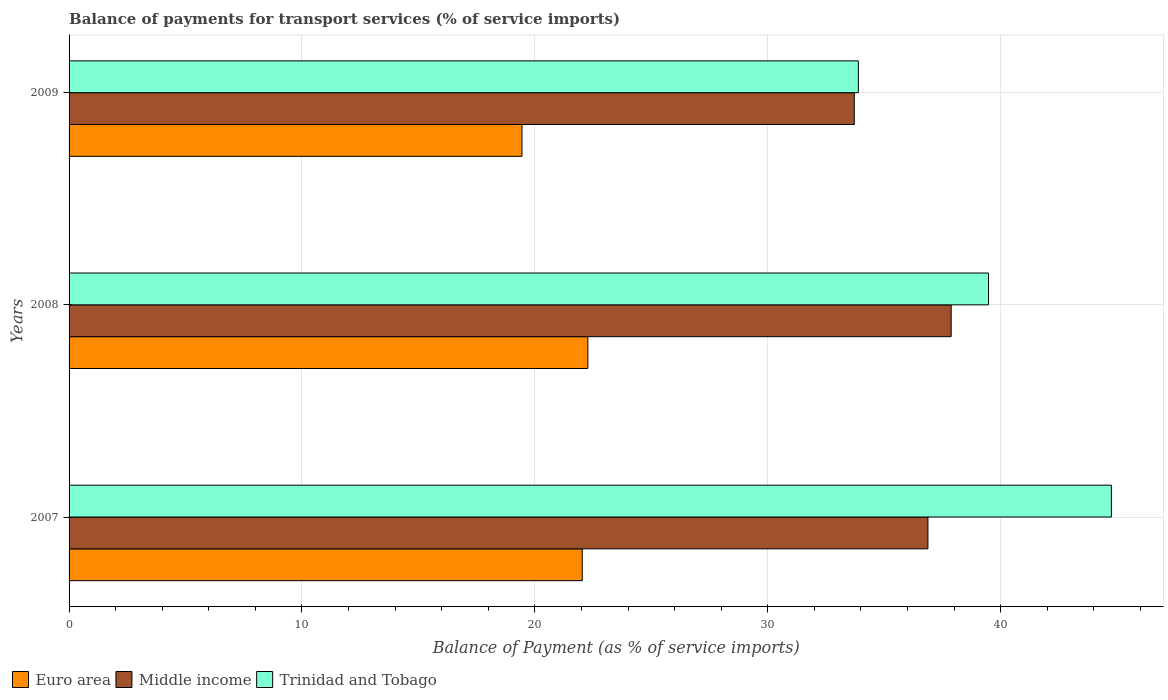How many groups of bars are there?
Offer a very short reply. 3. What is the balance of payments for transport services in Euro area in 2009?
Provide a succinct answer. 19.45. Across all years, what is the maximum balance of payments for transport services in Euro area?
Your response must be concise. 22.28. Across all years, what is the minimum balance of payments for transport services in Trinidad and Tobago?
Offer a terse response. 33.89. In which year was the balance of payments for transport services in Euro area maximum?
Your answer should be very brief. 2008. What is the total balance of payments for transport services in Trinidad and Tobago in the graph?
Your answer should be very brief. 118.12. What is the difference between the balance of payments for transport services in Trinidad and Tobago in 2007 and that in 2008?
Your answer should be very brief. 5.28. What is the difference between the balance of payments for transport services in Trinidad and Tobago in 2009 and the balance of payments for transport services in Middle income in 2008?
Provide a short and direct response. -3.99. What is the average balance of payments for transport services in Middle income per year?
Keep it short and to the point. 36.16. In the year 2007, what is the difference between the balance of payments for transport services in Middle income and balance of payments for transport services in Trinidad and Tobago?
Make the answer very short. -7.88. What is the ratio of the balance of payments for transport services in Euro area in 2007 to that in 2009?
Provide a succinct answer. 1.13. Is the difference between the balance of payments for transport services in Middle income in 2007 and 2009 greater than the difference between the balance of payments for transport services in Trinidad and Tobago in 2007 and 2009?
Your answer should be very brief. No. What is the difference between the highest and the second highest balance of payments for transport services in Trinidad and Tobago?
Give a very brief answer. 5.28. What is the difference between the highest and the lowest balance of payments for transport services in Trinidad and Tobago?
Offer a terse response. 10.86. What does the 1st bar from the bottom in 2009 represents?
Provide a short and direct response. Euro area. Are all the bars in the graph horizontal?
Offer a very short reply. Yes. Are the values on the major ticks of X-axis written in scientific E-notation?
Offer a terse response. No. Does the graph contain grids?
Your answer should be very brief. Yes. How are the legend labels stacked?
Your response must be concise. Horizontal. What is the title of the graph?
Offer a terse response. Balance of payments for transport services (% of service imports). What is the label or title of the X-axis?
Offer a very short reply. Balance of Payment (as % of service imports). What is the Balance of Payment (as % of service imports) in Euro area in 2007?
Your answer should be compact. 22.04. What is the Balance of Payment (as % of service imports) of Middle income in 2007?
Your answer should be compact. 36.88. What is the Balance of Payment (as % of service imports) in Trinidad and Tobago in 2007?
Ensure brevity in your answer.  44.75. What is the Balance of Payment (as % of service imports) in Euro area in 2008?
Offer a terse response. 22.28. What is the Balance of Payment (as % of service imports) in Middle income in 2008?
Your response must be concise. 37.88. What is the Balance of Payment (as % of service imports) of Trinidad and Tobago in 2008?
Your response must be concise. 39.48. What is the Balance of Payment (as % of service imports) in Euro area in 2009?
Your response must be concise. 19.45. What is the Balance of Payment (as % of service imports) of Middle income in 2009?
Offer a terse response. 33.72. What is the Balance of Payment (as % of service imports) in Trinidad and Tobago in 2009?
Give a very brief answer. 33.89. Across all years, what is the maximum Balance of Payment (as % of service imports) in Euro area?
Your response must be concise. 22.28. Across all years, what is the maximum Balance of Payment (as % of service imports) of Middle income?
Your response must be concise. 37.88. Across all years, what is the maximum Balance of Payment (as % of service imports) in Trinidad and Tobago?
Give a very brief answer. 44.75. Across all years, what is the minimum Balance of Payment (as % of service imports) in Euro area?
Make the answer very short. 19.45. Across all years, what is the minimum Balance of Payment (as % of service imports) in Middle income?
Give a very brief answer. 33.72. Across all years, what is the minimum Balance of Payment (as % of service imports) of Trinidad and Tobago?
Your answer should be compact. 33.89. What is the total Balance of Payment (as % of service imports) of Euro area in the graph?
Keep it short and to the point. 63.76. What is the total Balance of Payment (as % of service imports) in Middle income in the graph?
Your answer should be very brief. 108.47. What is the total Balance of Payment (as % of service imports) of Trinidad and Tobago in the graph?
Keep it short and to the point. 118.12. What is the difference between the Balance of Payment (as % of service imports) in Euro area in 2007 and that in 2008?
Give a very brief answer. -0.24. What is the difference between the Balance of Payment (as % of service imports) of Middle income in 2007 and that in 2008?
Make the answer very short. -1. What is the difference between the Balance of Payment (as % of service imports) in Trinidad and Tobago in 2007 and that in 2008?
Your answer should be compact. 5.28. What is the difference between the Balance of Payment (as % of service imports) of Euro area in 2007 and that in 2009?
Provide a short and direct response. 2.59. What is the difference between the Balance of Payment (as % of service imports) of Middle income in 2007 and that in 2009?
Keep it short and to the point. 3.16. What is the difference between the Balance of Payment (as % of service imports) in Trinidad and Tobago in 2007 and that in 2009?
Offer a terse response. 10.86. What is the difference between the Balance of Payment (as % of service imports) of Euro area in 2008 and that in 2009?
Your answer should be very brief. 2.83. What is the difference between the Balance of Payment (as % of service imports) in Middle income in 2008 and that in 2009?
Make the answer very short. 4.16. What is the difference between the Balance of Payment (as % of service imports) of Trinidad and Tobago in 2008 and that in 2009?
Your response must be concise. 5.59. What is the difference between the Balance of Payment (as % of service imports) of Euro area in 2007 and the Balance of Payment (as % of service imports) of Middle income in 2008?
Your response must be concise. -15.84. What is the difference between the Balance of Payment (as % of service imports) of Euro area in 2007 and the Balance of Payment (as % of service imports) of Trinidad and Tobago in 2008?
Your response must be concise. -17.44. What is the difference between the Balance of Payment (as % of service imports) in Middle income in 2007 and the Balance of Payment (as % of service imports) in Trinidad and Tobago in 2008?
Your answer should be compact. -2.6. What is the difference between the Balance of Payment (as % of service imports) of Euro area in 2007 and the Balance of Payment (as % of service imports) of Middle income in 2009?
Give a very brief answer. -11.68. What is the difference between the Balance of Payment (as % of service imports) in Euro area in 2007 and the Balance of Payment (as % of service imports) in Trinidad and Tobago in 2009?
Provide a succinct answer. -11.85. What is the difference between the Balance of Payment (as % of service imports) in Middle income in 2007 and the Balance of Payment (as % of service imports) in Trinidad and Tobago in 2009?
Keep it short and to the point. 2.99. What is the difference between the Balance of Payment (as % of service imports) in Euro area in 2008 and the Balance of Payment (as % of service imports) in Middle income in 2009?
Keep it short and to the point. -11.44. What is the difference between the Balance of Payment (as % of service imports) of Euro area in 2008 and the Balance of Payment (as % of service imports) of Trinidad and Tobago in 2009?
Your response must be concise. -11.61. What is the difference between the Balance of Payment (as % of service imports) in Middle income in 2008 and the Balance of Payment (as % of service imports) in Trinidad and Tobago in 2009?
Your response must be concise. 3.99. What is the average Balance of Payment (as % of service imports) of Euro area per year?
Make the answer very short. 21.25. What is the average Balance of Payment (as % of service imports) in Middle income per year?
Your answer should be very brief. 36.16. What is the average Balance of Payment (as % of service imports) of Trinidad and Tobago per year?
Offer a terse response. 39.37. In the year 2007, what is the difference between the Balance of Payment (as % of service imports) in Euro area and Balance of Payment (as % of service imports) in Middle income?
Your answer should be compact. -14.84. In the year 2007, what is the difference between the Balance of Payment (as % of service imports) of Euro area and Balance of Payment (as % of service imports) of Trinidad and Tobago?
Provide a short and direct response. -22.72. In the year 2007, what is the difference between the Balance of Payment (as % of service imports) of Middle income and Balance of Payment (as % of service imports) of Trinidad and Tobago?
Give a very brief answer. -7.88. In the year 2008, what is the difference between the Balance of Payment (as % of service imports) in Euro area and Balance of Payment (as % of service imports) in Middle income?
Your response must be concise. -15.6. In the year 2008, what is the difference between the Balance of Payment (as % of service imports) of Euro area and Balance of Payment (as % of service imports) of Trinidad and Tobago?
Your response must be concise. -17.2. In the year 2008, what is the difference between the Balance of Payment (as % of service imports) in Middle income and Balance of Payment (as % of service imports) in Trinidad and Tobago?
Your answer should be compact. -1.6. In the year 2009, what is the difference between the Balance of Payment (as % of service imports) in Euro area and Balance of Payment (as % of service imports) in Middle income?
Your response must be concise. -14.27. In the year 2009, what is the difference between the Balance of Payment (as % of service imports) of Euro area and Balance of Payment (as % of service imports) of Trinidad and Tobago?
Give a very brief answer. -14.44. In the year 2009, what is the difference between the Balance of Payment (as % of service imports) in Middle income and Balance of Payment (as % of service imports) in Trinidad and Tobago?
Provide a succinct answer. -0.17. What is the ratio of the Balance of Payment (as % of service imports) in Middle income in 2007 to that in 2008?
Give a very brief answer. 0.97. What is the ratio of the Balance of Payment (as % of service imports) of Trinidad and Tobago in 2007 to that in 2008?
Make the answer very short. 1.13. What is the ratio of the Balance of Payment (as % of service imports) in Euro area in 2007 to that in 2009?
Make the answer very short. 1.13. What is the ratio of the Balance of Payment (as % of service imports) of Middle income in 2007 to that in 2009?
Ensure brevity in your answer.  1.09. What is the ratio of the Balance of Payment (as % of service imports) in Trinidad and Tobago in 2007 to that in 2009?
Provide a short and direct response. 1.32. What is the ratio of the Balance of Payment (as % of service imports) in Euro area in 2008 to that in 2009?
Your answer should be very brief. 1.15. What is the ratio of the Balance of Payment (as % of service imports) of Middle income in 2008 to that in 2009?
Keep it short and to the point. 1.12. What is the ratio of the Balance of Payment (as % of service imports) in Trinidad and Tobago in 2008 to that in 2009?
Keep it short and to the point. 1.16. What is the difference between the highest and the second highest Balance of Payment (as % of service imports) in Euro area?
Keep it short and to the point. 0.24. What is the difference between the highest and the second highest Balance of Payment (as % of service imports) in Middle income?
Offer a terse response. 1. What is the difference between the highest and the second highest Balance of Payment (as % of service imports) of Trinidad and Tobago?
Offer a terse response. 5.28. What is the difference between the highest and the lowest Balance of Payment (as % of service imports) in Euro area?
Keep it short and to the point. 2.83. What is the difference between the highest and the lowest Balance of Payment (as % of service imports) in Middle income?
Give a very brief answer. 4.16. What is the difference between the highest and the lowest Balance of Payment (as % of service imports) of Trinidad and Tobago?
Ensure brevity in your answer.  10.86. 